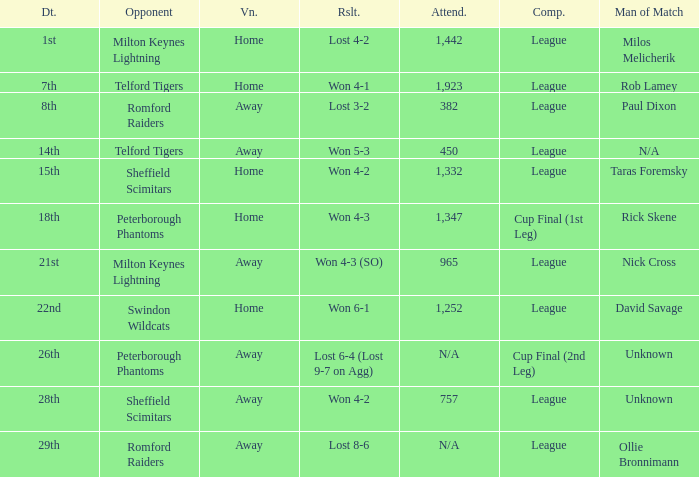What was the date when the attendance was n/a and the Man of the Match was unknown? 26th. 